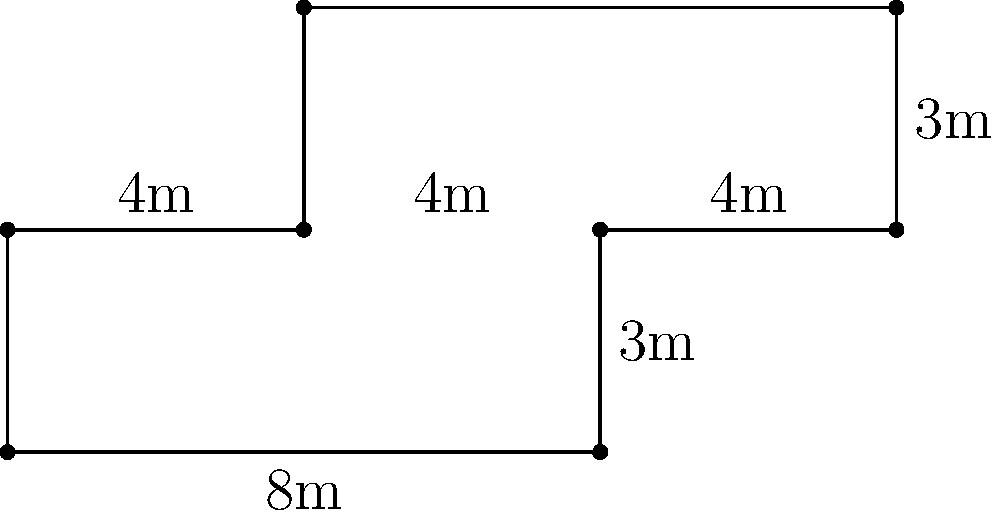As the owner of the village's only grocery store, you're planning to install new baseboards along the entire perimeter of your irregularly shaped store floor. Calculate the total length of baseboards needed in meters. To calculate the perimeter of the irregularly shaped store floor, we need to sum up the lengths of all sides:

1. Bottom side: $8$ m
2. Right side (lower part): $3$ m
3. Right side (upper part): $3$ m
4. Top side: $8$ m (from $12$ m to $4$ m)
5. Left side (upper part): $3$ m
6. Middle vertical section: $4$ m
7. Left side (lower part): $3$ m

Adding all these lengths:

$$\text{Perimeter} = 8 + 3 + 3 + 8 + 3 + 4 + 3 = 32 \text{ m}$$

Therefore, the total length of baseboards needed is 32 meters.
Answer: 32 m 